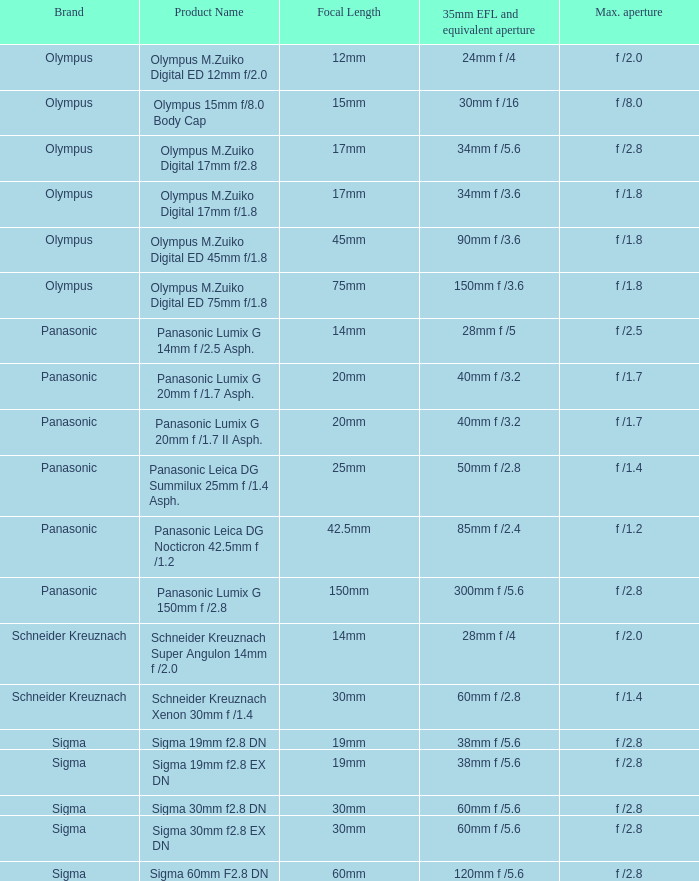What is the maximum aperture of the lens(es) with a focal length of 20mm? F /1.7, f /1.7. 